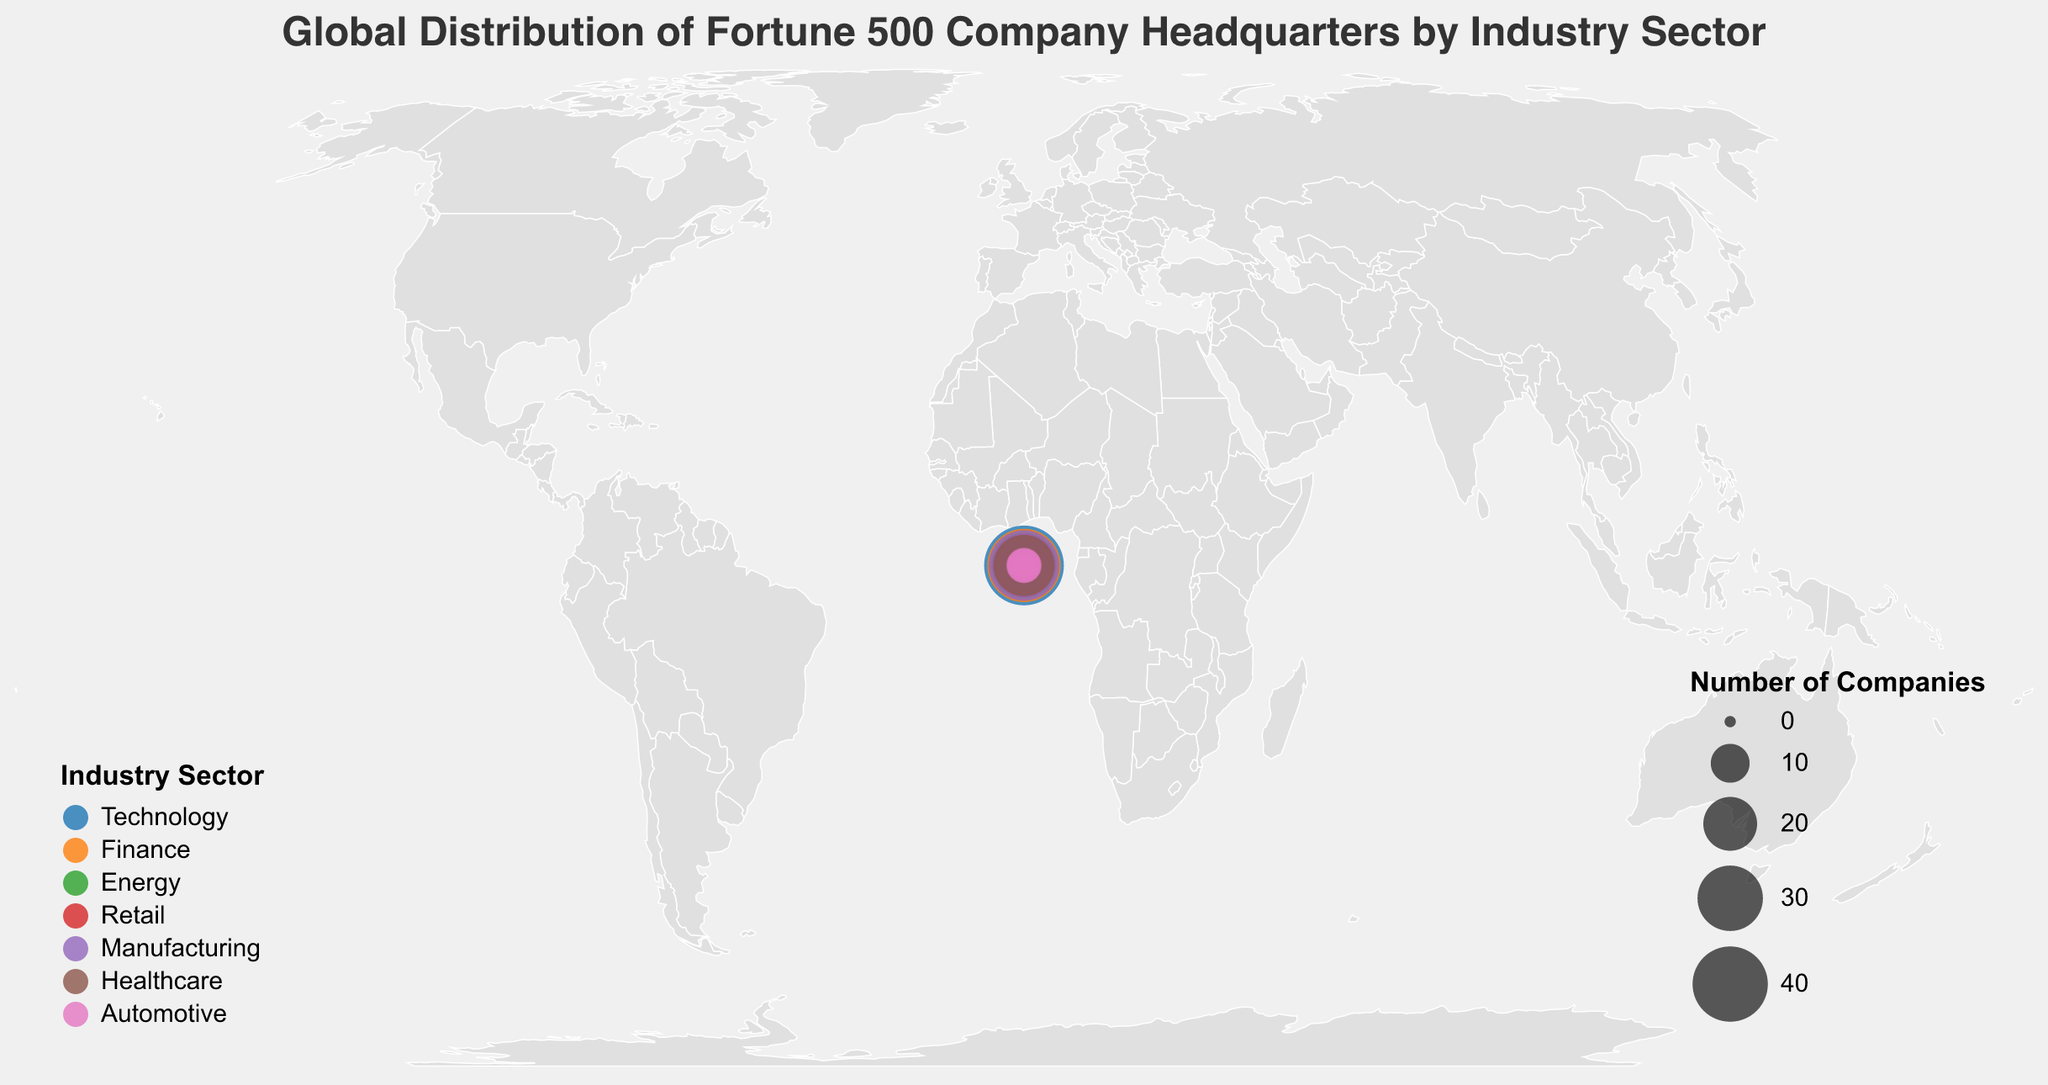Which country has the highest number of Fortune 500 company headquarters in the Technology sector? By looking at the colored circles representing each industry, we find the largest circle in the Technology sector is in the United States.
Answer: United States Which industry has the second-largest number of companies headquartered in China? Reviewing the circles under China's location for each industry and comparing their sizes, the second-largest after Technology is Manufacturing.
Answer: Manufacturing How many Fortune 500 company headquarters are there in Germany across all industries? Summing the number of companies in Germany for each industry: Energy (5) + Retail (7) + Manufacturing (10) + Healthcare (3) + Automotive (7), we get 5 + 7 + 10 + 3 + 7 = 32.
Answer: 32 Which industry in Japan has more Fortune 500 company headquarters, Technology or Automotive? Comparing the circles for Technology and Automotive in Japan, Technology has 12 companies while Automotive has 8.
Answer: Technology Which industry sector has the most Fortune 500 company headquarters in the United States? Reviewing the size of the circles in the United States for each industry sector, Technology has the largest circle with 45 companies.
Answer: Technology What is the sum of Fortune 500 company headquarters in the Finance sector of France and the Healthcare sector of Germany? Adding the number of companies (Finance in France: 7) and (Healthcare in Germany: 3), we get 7 + 3 = 10.
Answer: 10 Does the Retail sector have more Fortune 500 company headquarters in Germany or Japan? Examining the circles for Retail in Germany and Japan, Germany has 7 companies while Japan has 9, making Japan higher.
Answer: Japan Which country has the least number of Fortune 500 company headquarters in the Healthcare sector? Comparing the circles in the Healthcare sector, Germany has the smallest circle with 3 companies.
Answer: Germany Are there more Fortune 500 company headquarters in the Manufacturing sector in China or the United States? Comparing the circles for Manufacturing in China and the United States, China has 35 companies while the United States has 22.
Answer: China 